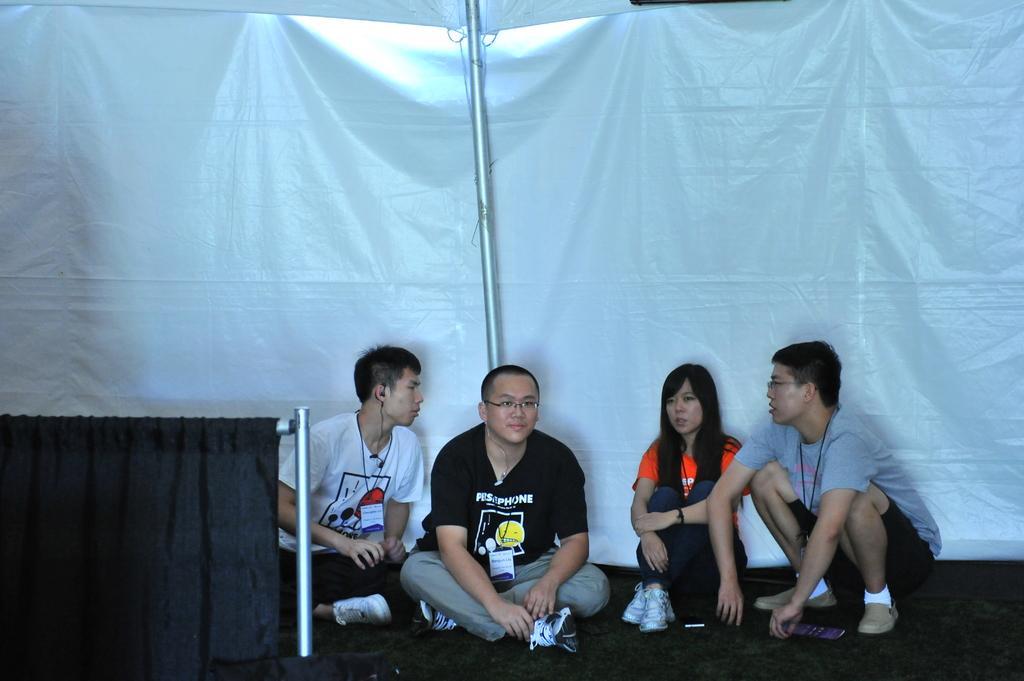Could you give a brief overview of what you see in this image? In this picture I can see four persons sitting on the floor, there is a pole, black curtain, and in the background there is a tarpaulin sheet. 